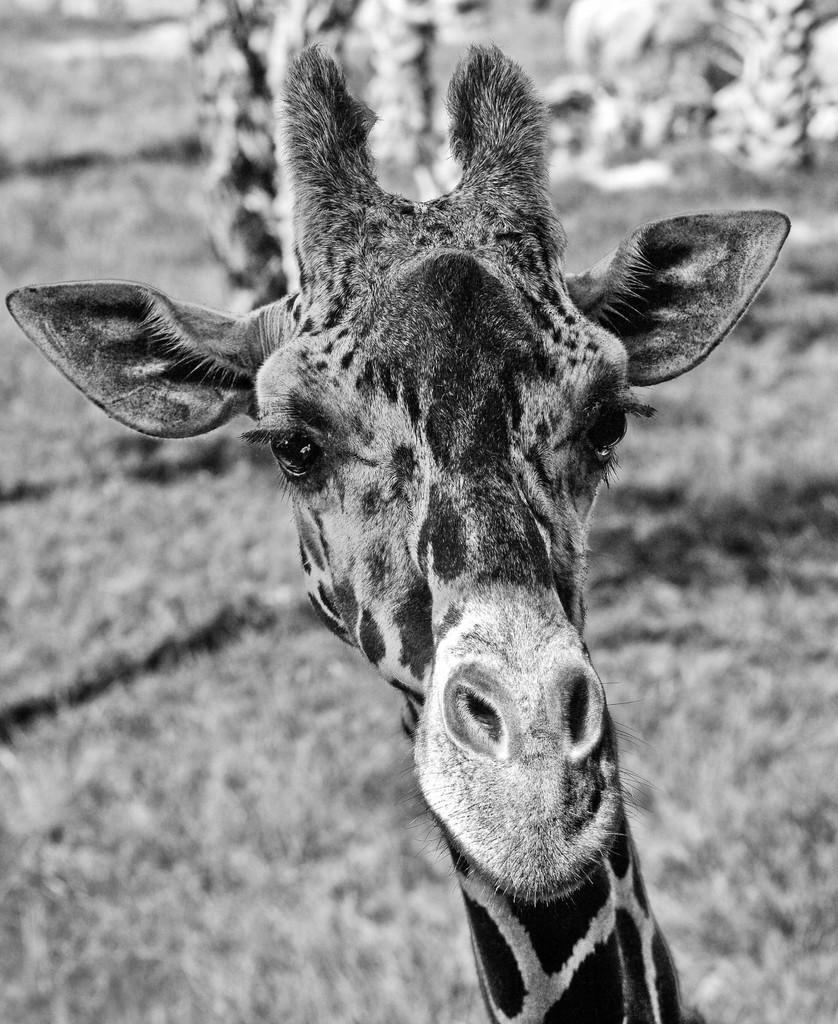What is the color scheme of the image? The image is black and white. What animal is featured in the image? There is a giraffe in the image. Can you describe the background of the image? The background of the image is blurred. How many fish can be seen swimming in the image? There are no fish present in the image; it features a giraffe. What type of whistle is being used by the giraffe in the image? There is no whistle present in the image, and giraffes do not use whistles. 